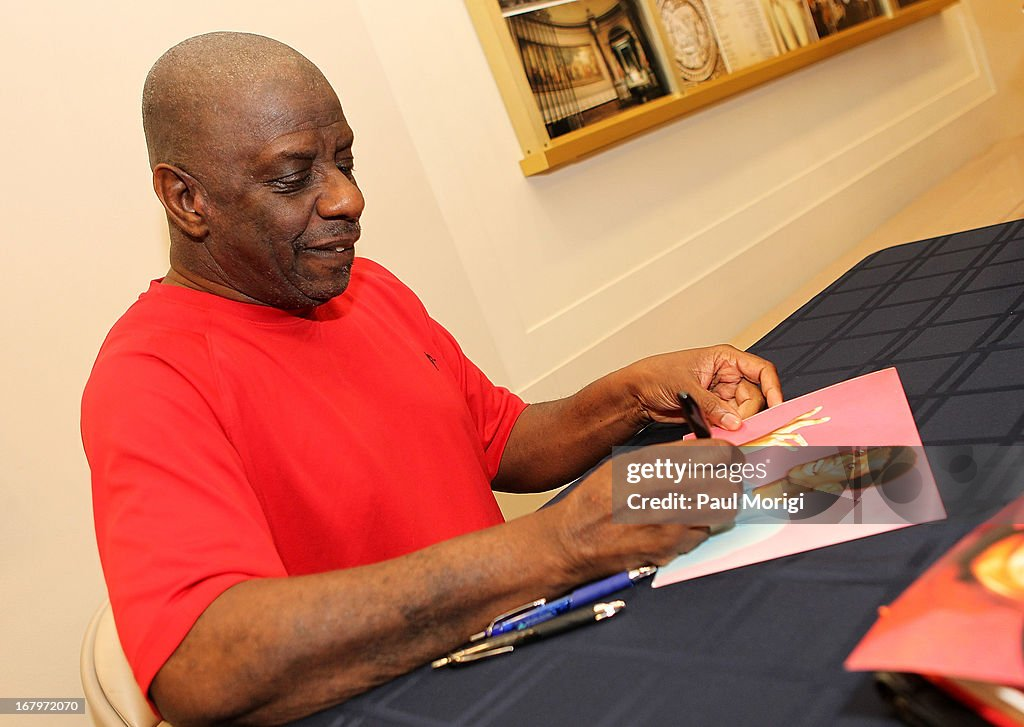What other events could be similar to this and what might they involve? Similar events might include book signings, where an author signs copies of their book; music album signings, where a musician signs CDs or vinyl records; and meet-and-greet sessions, where fans can get autographs and photos with a celebrity. These events typically involve fans bringing items to be signed, waiting in line for their turn, and a quick interaction with the guest of honor. 